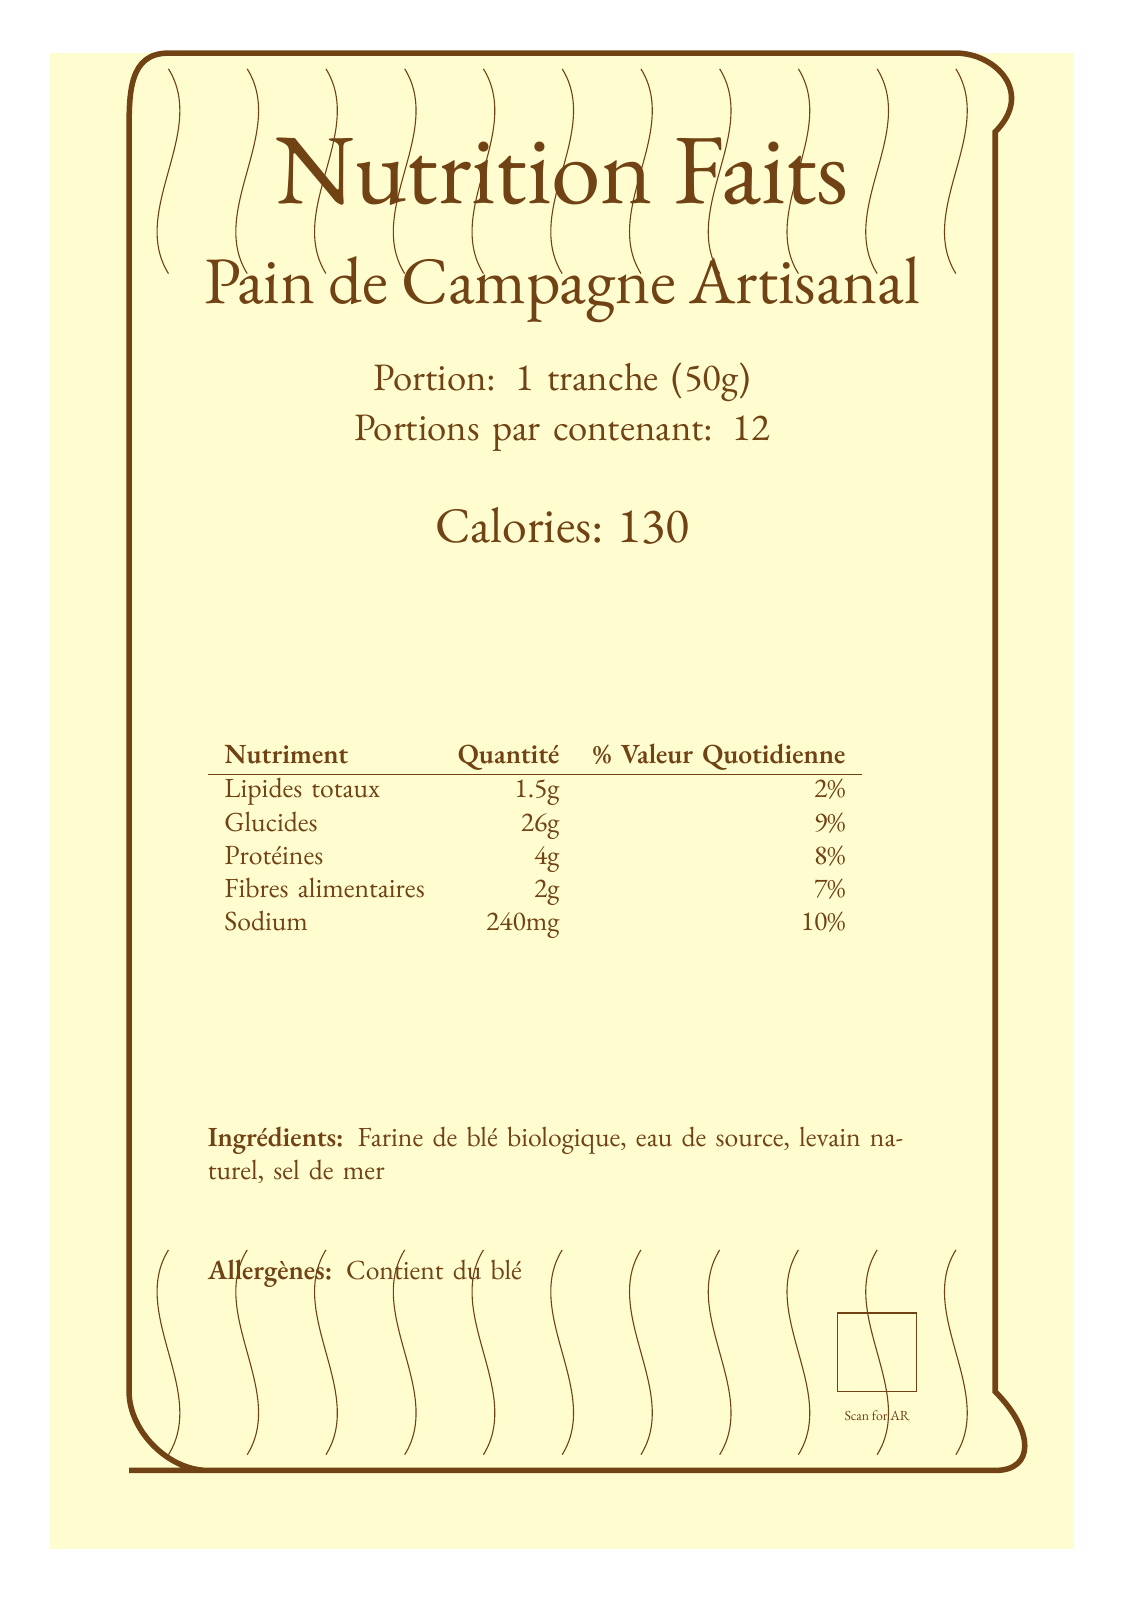who is the artist mentioned in the historical reference? The historical reference section mentions Alphonse Mucha as a significant artist during the Belle Époque era.
Answer: Alphonse Mucha what type of ink is used on the label? The innovative features section specifies that the label is printed using sustainable, plant-based ink that changes color with temperature.
Answer: Plant-based ink what is the serving size of the bread? The serving information section states that the serving size is 1 tranche (50g).
Answer: 1 tranche (50g) how many calories are in one serving of the bread? The calories section states that there are 130 calories per serving.
Answer: 130 what allergens are present in the product? The allergens section mentions that the product contains wheat.
Answer: Wheat where can you find detailed nutritional visualization? A. Ingredients list B. QR code C. Border design D. Typography style The QR code in the lower section is linked to a 3D nutritional visualization.
Answer: B which era is the label inspired by? A. Renaissance B. Belle Époque C. Victorian D. Art Deco The historical reference states that the label is inspired by the Belle Époque era.
Answer: B does the document comply with FDA readability requirements? The modern challenges section mentions balancing aesthetics with FDA readability requirements but doesn't confirm compliance.
Answer: Not enough information is there an augmented reality feature? The innovative features section lists augmented reality integration as a feature of the label.
Answer: Yes describe the main design elements and features of the document Each section of the document presents specific information, from nutritional values to designer notes, combining historical inspiration with modern technology and innovation to create a unique label.
Answer: The document is a Nutrition Facts label for artisanal bread with Art Nouveau design elements, including an ornate border, custom typography, and embellishments such as wheat stalks. It includes nutrition information, ingredients, allergens, and has innovative features like a QR code for AR integration, interactive typography, and sustainable ink. The design balances historical aesthetics with modern digital and sustainability challenges. what kind of flour is used in the bread? The ingredients section states that the bread is made with organic wheat flour.
Answer: Organic wheat flour what is the daily value percentage for sodium? The nutrition facts table shows that the daily value for sodium is 10%.
Answer: 10% how are the flourishes in the typography designed to interact? The interactive typography feature mentions that the flourishes animate in response to touch or hover.
Answer: They respond to touch or hover what kind of color palette is suggested in the designer notes? The designer notes suggest using a color palette inspired by Toulouse-Lautrec posters.
Answer: Inspired by Toulouse-Lautrec posters 